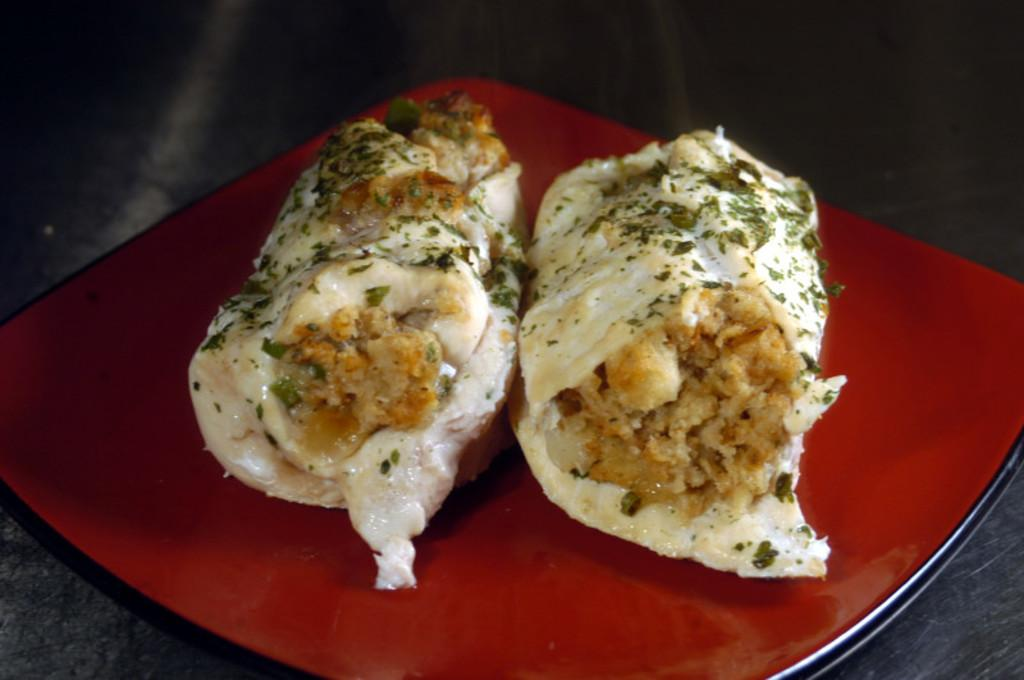What is on the plate that is visible in the image? There is a plate with food in the image. Where is the plate located in the image? The plate is on a platform in the image. What type of locket can be seen hanging from the plate in the image? There is no locket present in the image; it only features a plate with food on a platform. 